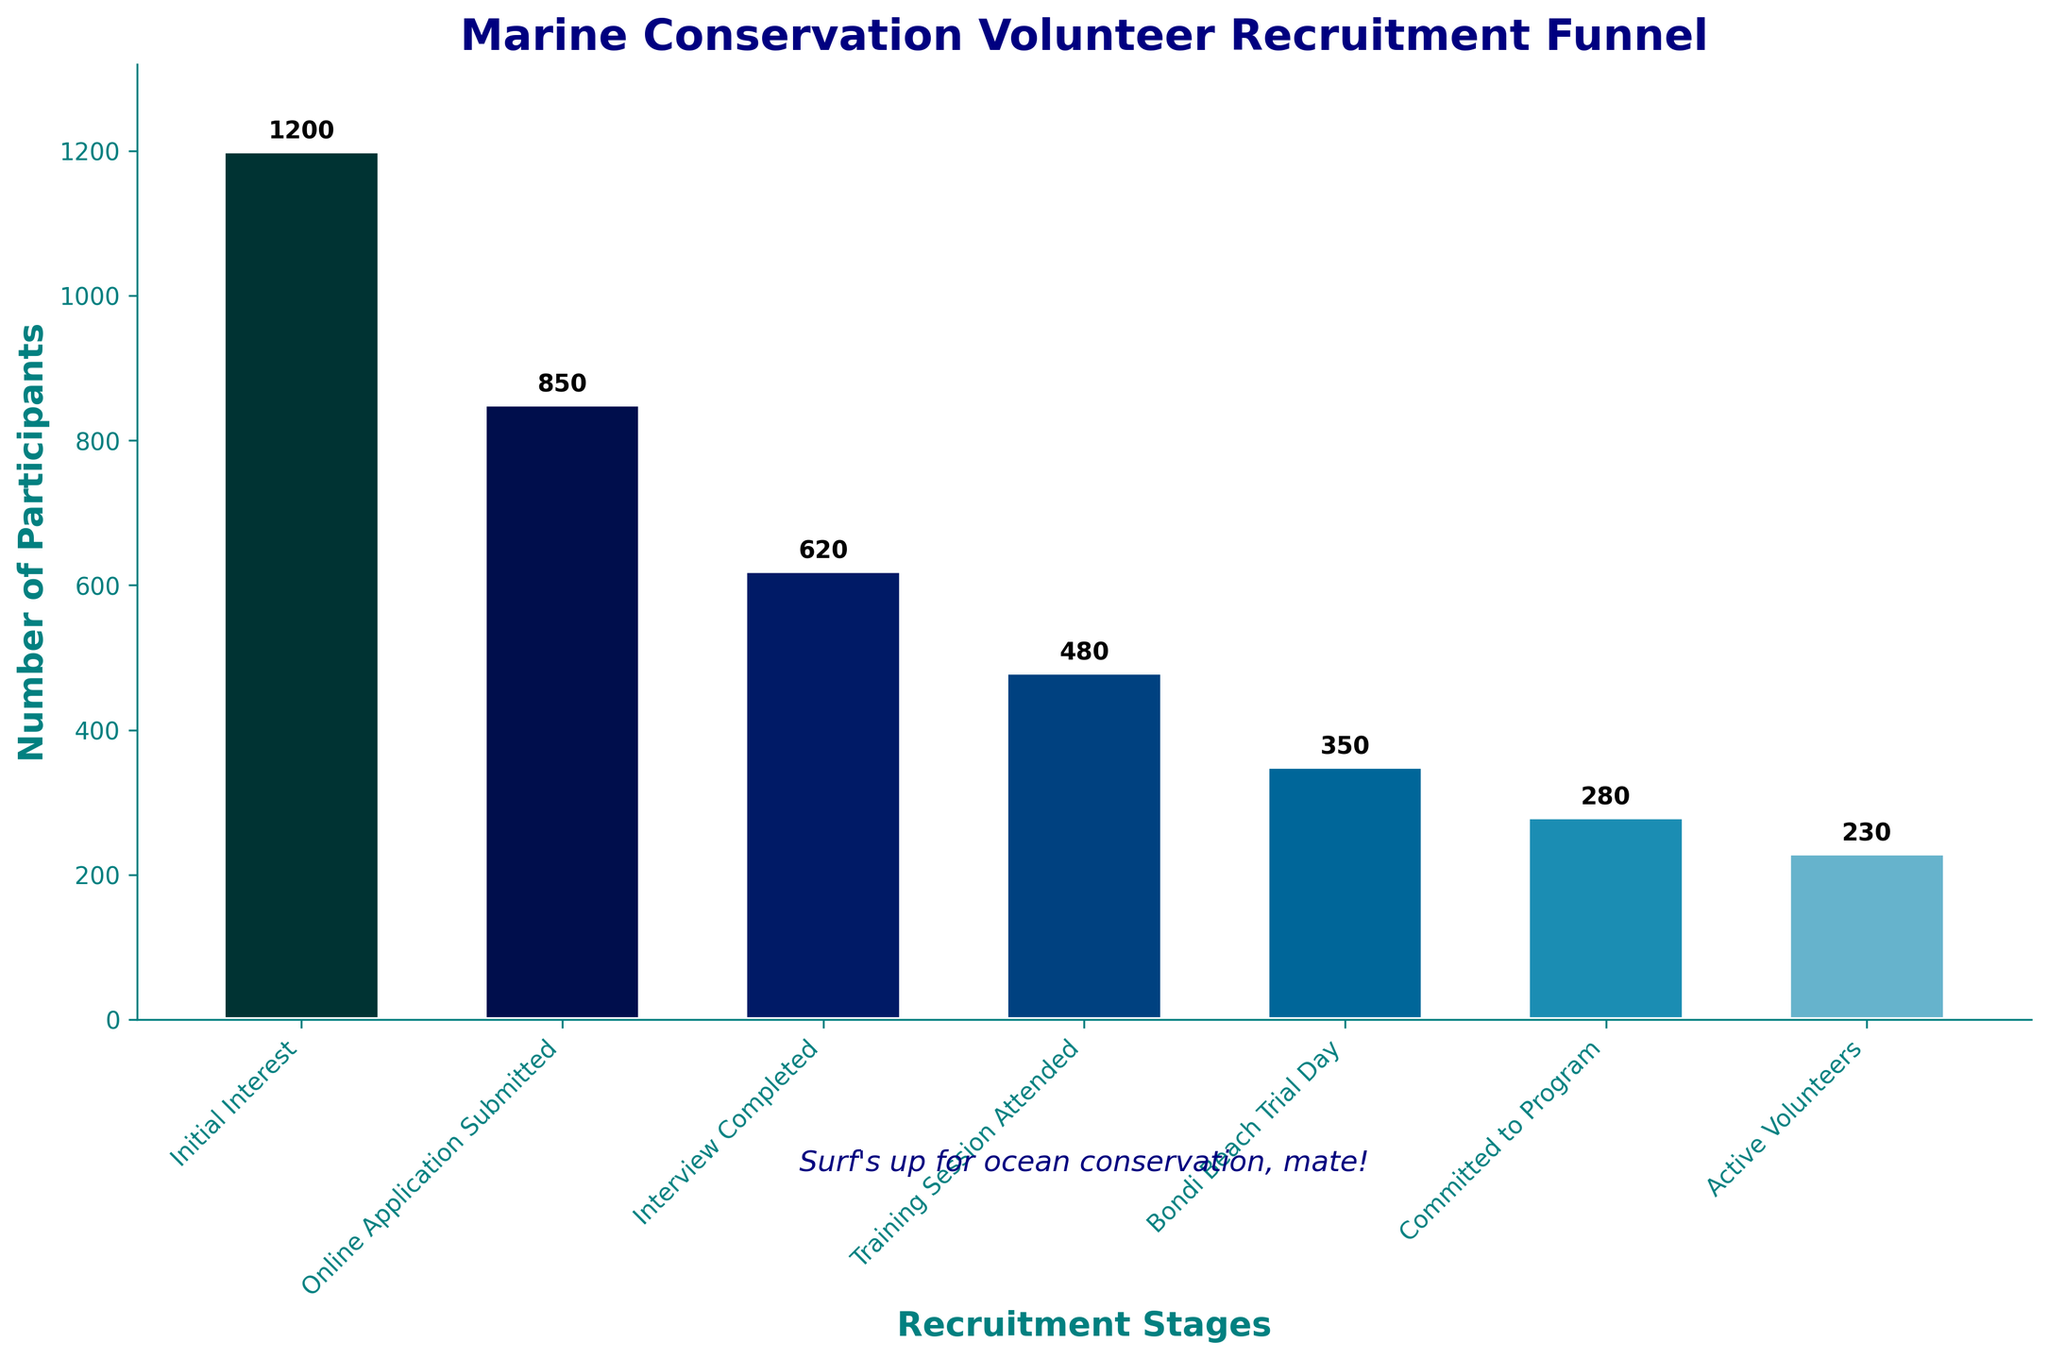What is the title of the chart? The title is usually placed at the top of the figure and is clearly visible in large, bold font. In this case, the title is "Marine Conservation Volunteer Recruitment Funnel"
Answer: Marine Conservation Volunteer Recruitment Funnel What stage has the highest number of participants? The first stage of the recruitment funnel generally starts with the highest number, which is seen as the tallest bar in the chart. Here, "Initial Interest" has the highest number with 1200 participants
Answer: Initial Interest Which stage comes immediately after "Interview Completed"? To answer this, follow the order of the stages listed from left to right in the funnel chart. After "Interview Completed," the next stage is "Training Session Attended"
Answer: Training Session Attended How many participants attended the "Bondi Beach Trial Day"? Locate the stage labeled "Bondi Beach Trial Day" in the funnel chart and refer to the number displayed at the top of its bar. The number of participants is 350
Answer: 350 What is the difference in the number of participants between the "Training Session Attended" and "Active Volunteers" stages? To find the difference, subtract the number of participants in the "Active Volunteers" stage (230) from the "Training Session Attended" stage (480). Calculation: 480 - 230 = 250
Answer: 250 Which stages see a drop of more than 200 participants compared to the previous stage? Compare participant numbers between consecutive stages and identify drops greater than 200. From "Initial Interest" to "Online Application Submitted" the drop is 1200 - 850 = 350. From "Online Application Submitted" to "Interview Completed" the drop is 850 - 620 = 230. From "Interview Completed" to "Training Session Attended" the drop is 620 - 480 = 140 (not considered). From "Training Session Attended" to "Bondi Beach Trial Day" the drop is 480 - 350 = 130 (not considered). The stages are "Initial Interest" to "Online Application Submitted" and "Online Application Submitted" to "Interview Completed”
Answer: Initial Interest to Online Application Submitted, Online Application Submitted to Interview Completed What percentage of participants from the "Initial Interest" stage made it to the "Bondi Beach Trial Day"? To find this percentage, divide the number of participants at "Bondi Beach Trial Day" (350) by the number at "Initial Interest" (1200) and multiply by 100. Calculation: (350/1200) * 100 = 29.17%
Answer: 29.17% How many total stages are in the recruitment funnel? Count the number of distinct stages listed in the data. There are 7 stages: "Initial Interest," "Online Application Submitted," "Interview Completed," "Training Session Attended," "Bondi Beach Trial Day," "Committed to Program," and "Active Volunteers"
Answer: 7 What is the ratio of participants who attended "Training Session" to those who ended up as "Active Volunteers"? Calculate the ratio by dividing the number of participants at "Training Session Attended" (480) by those at "Active Volunteers" (230). Calculation: 480 / 230 ≈ 2.09
Answer: 2.09 Which stage has the lowest number of participants? The final stage usually shows the smallest number since it represents the end of the funnel. Here, "Active Volunteers" has the lowest number with 230 participants
Answer: Active Volunteers 